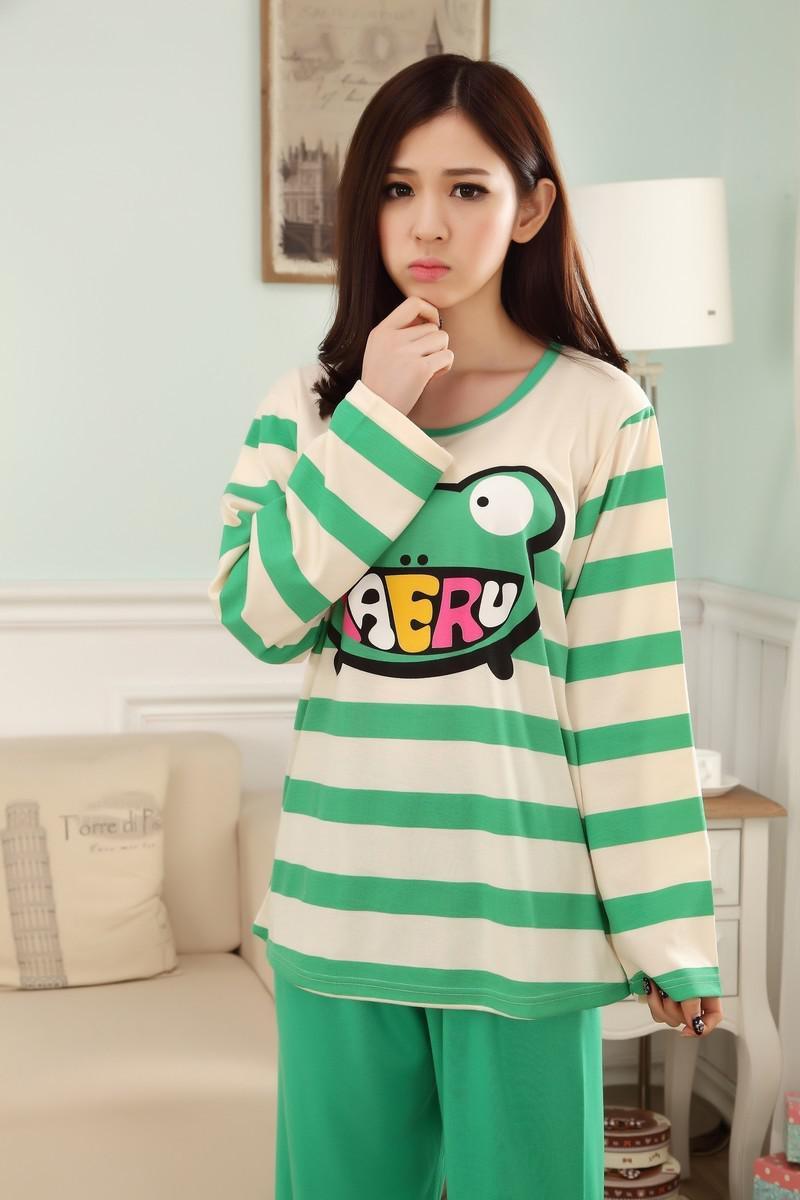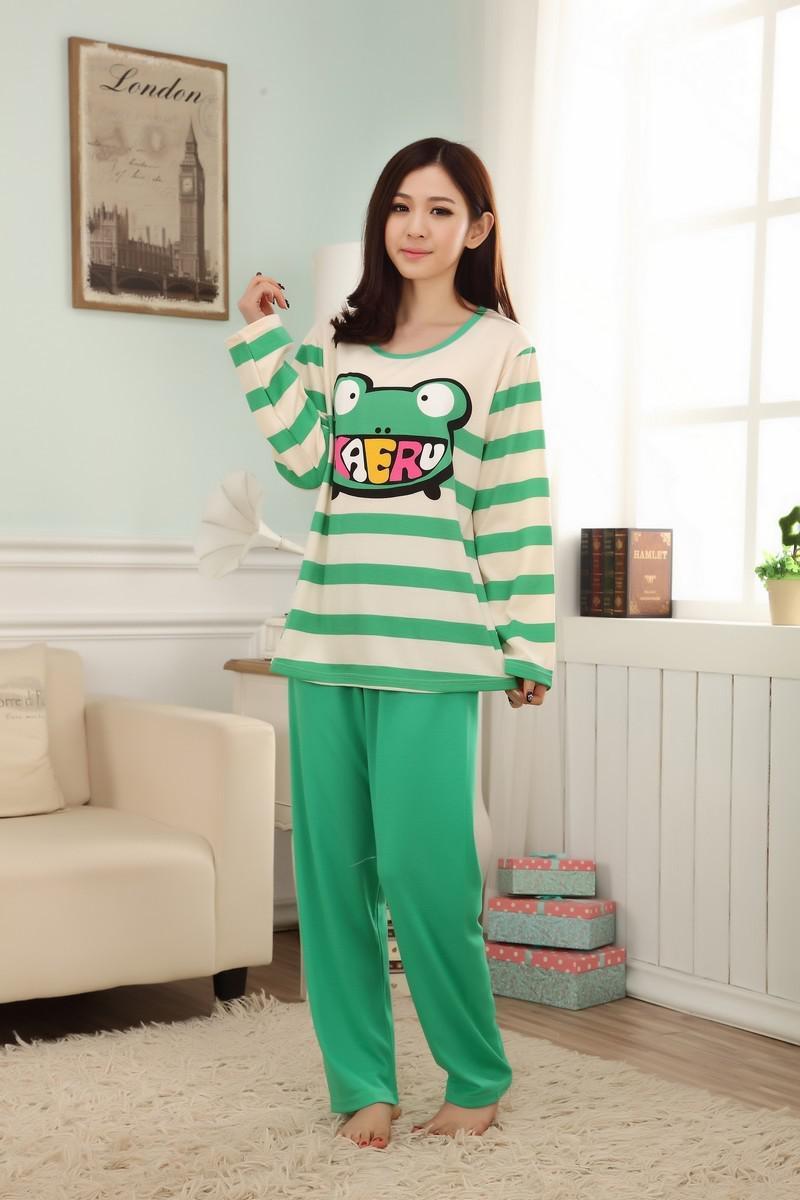The first image is the image on the left, the second image is the image on the right. For the images shown, is this caption "The right image contains a lady wearing pajamas featuring a large teddy bear, not a frog, with a window and a couch in the background." true? Answer yes or no. No. The first image is the image on the left, the second image is the image on the right. For the images displayed, is the sentence "One image shows a model in pink loungewear featuring a face on it." factually correct? Answer yes or no. No. 